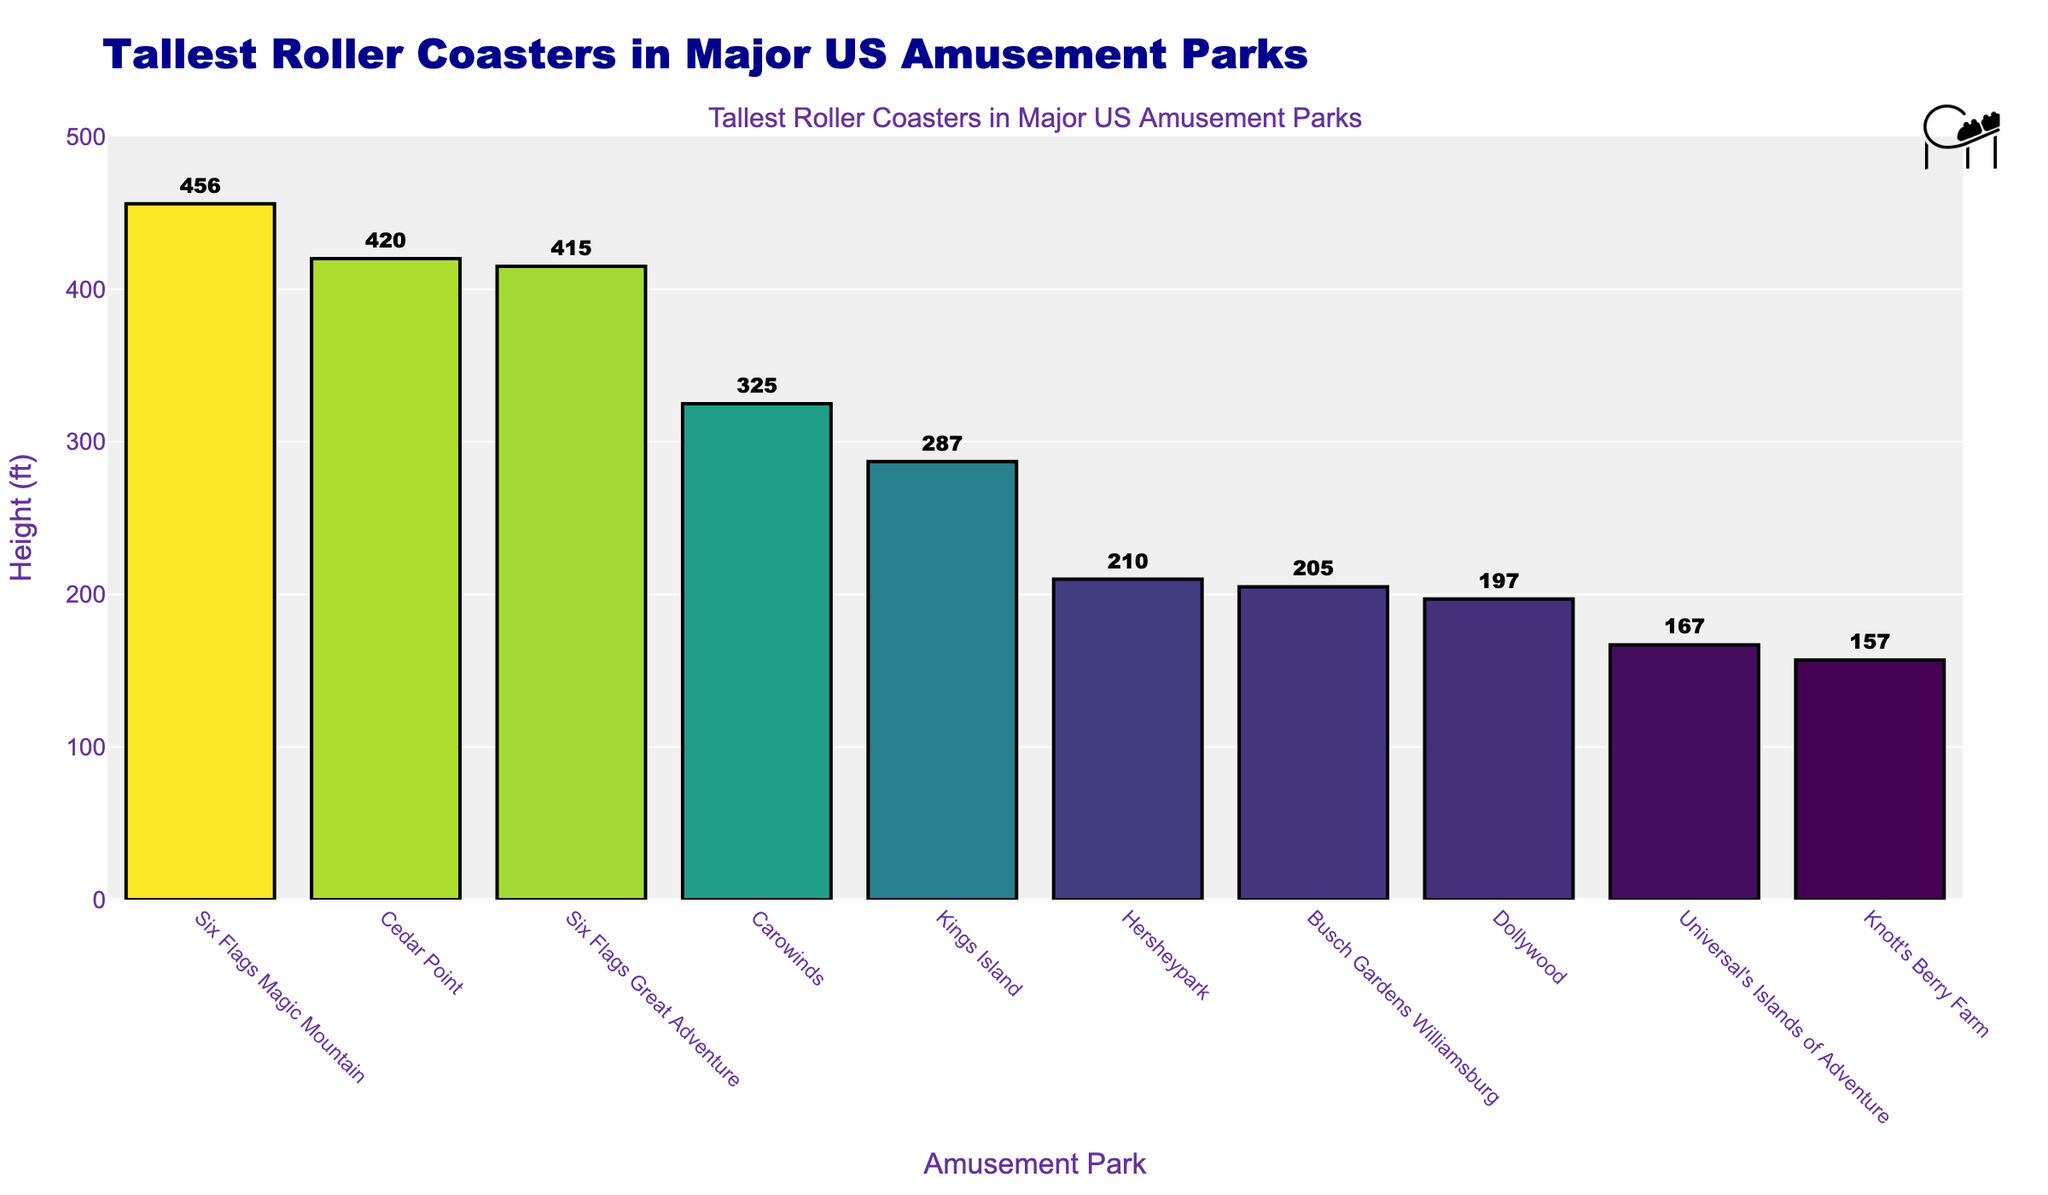What's the tallest roller coaster height among the listed amusement parks? The tallest roller coaster height can be found by looking at the height of the highest bar in the chart. The bar labeled "Six Flags Magic Mountain" is the tallest, indicating its height.
Answer: 456 ft Which amusement park features the shortest roller coaster among the parks listed? To determine the park with the shortest roller coaster, look for the shortest bar in the chart. The shortest bar is labeled "Knott's Berry Farm."
Answer: 157 ft How many roller coasters are taller than 400 ft? Count the number of bars that extend beyond the 400 ft mark on the y-axis. The bars for Six Flags Magic Mountain, Cedar Point, and Six Flags Great Adventure surpass this mark.
Answer: 3 By how much does the tallest roller coaster exceed the second tallest? Locate the bars for the tallest roller coaster (Six Flags Magic Mountain) and the second tallest (Cedar Point). Compare their heights: 456 ft (Six Flags Magic Mountain) and 420 ft (Cedar Point), then calculate the difference (456 - 420).
Answer: 36 ft Which amusement park(s) have roller coasters that are between 200 ft and 300 ft tall? Identify the bars that fall within the 200 ft to 300 ft range on the y-axis. The bars for Hersheypark (210 ft) and Kings Island (287 ft) fall within this range.
Answer: Hersheypark and Kings Island What is the combined height of the roller coasters at Six Flags Magic Mountain and Dollywood? Add the heights of the roller coasters at Six Flags Magic Mountain and Dollywood: 456 ft (Six Flags Magic Mountain) + 197 ft (Dollywood).
Answer: 653 ft How does the height of Carowinds' roller coaster compare to that of Busch Gardens Williamsburg? Find the heights of the roller coasters for Carowinds (325 ft) and Busch Gardens Williamsburg (205 ft) and compare them. Carowinds' is taller.
Answer: Carowinds is taller by 120 ft Which roller coaster height is closest to the median height of all listed parks? First, sort the heights in ascending order: 157, 167, 197, 205, 210, 287, 325, 415, 420, 456. The median falls between the 5th and 6th values (210 and 287); the average of these heights is (210+287)/2 = 248.5 ft. Find the height closest to this value.
Answer: Kings Island with 287 ft What percentage of the amusement parks have roller coasters taller than 300 ft? Determine the total number of parks listed (10) and count those with roller coasters taller than 300 ft (Six Flags Magic Mountain, Cedar Point, Six Flags Great Adventure, and Carowinds). Then calculate the percentage: (4/10) * 100% = 40%.
Answer: 40% 